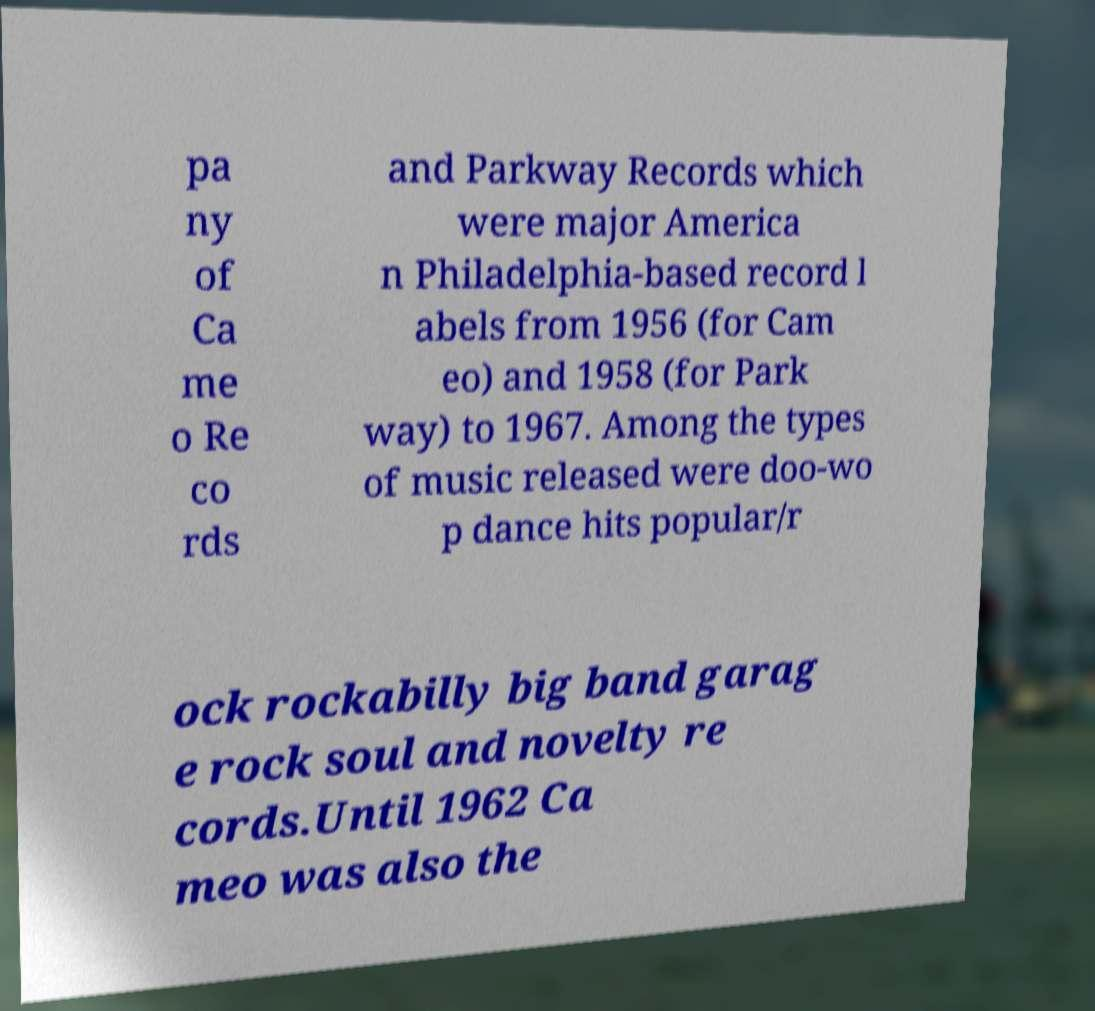I need the written content from this picture converted into text. Can you do that? pa ny of Ca me o Re co rds and Parkway Records which were major America n Philadelphia-based record l abels from 1956 (for Cam eo) and 1958 (for Park way) to 1967. Among the types of music released were doo-wo p dance hits popular/r ock rockabilly big band garag e rock soul and novelty re cords.Until 1962 Ca meo was also the 